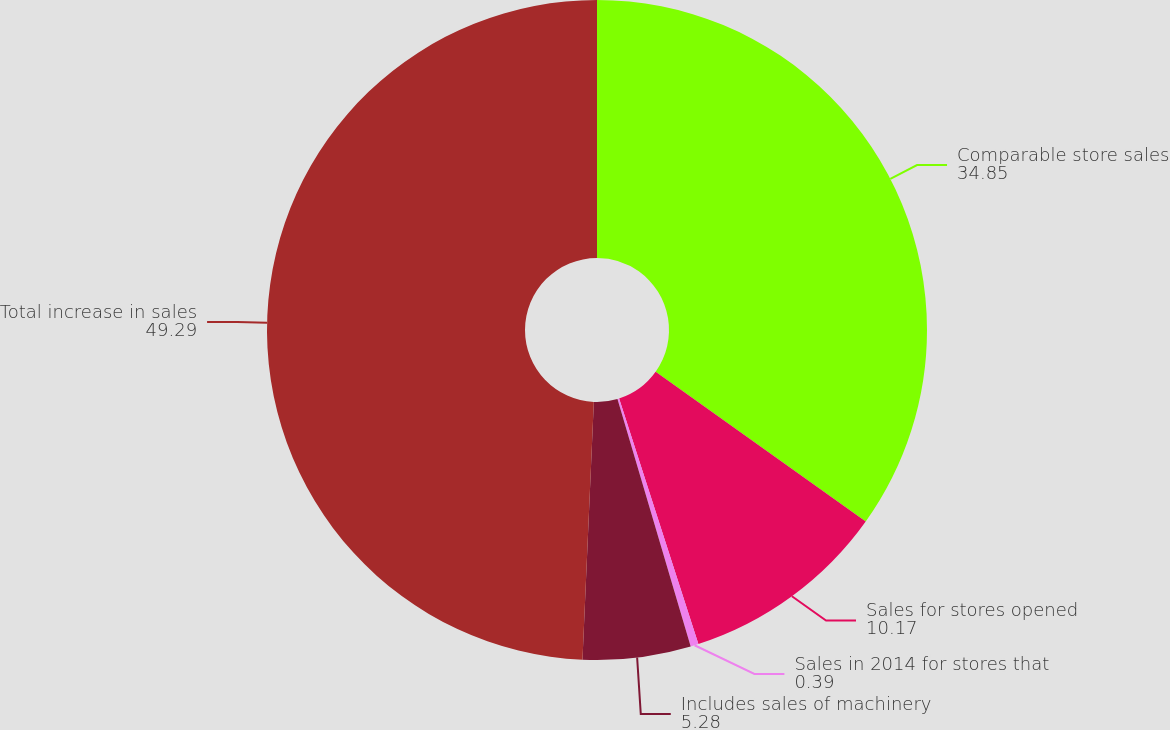Convert chart. <chart><loc_0><loc_0><loc_500><loc_500><pie_chart><fcel>Comparable store sales<fcel>Sales for stores opened<fcel>Sales in 2014 for stores that<fcel>Includes sales of machinery<fcel>Total increase in sales<nl><fcel>34.85%<fcel>10.17%<fcel>0.39%<fcel>5.28%<fcel>49.29%<nl></chart> 